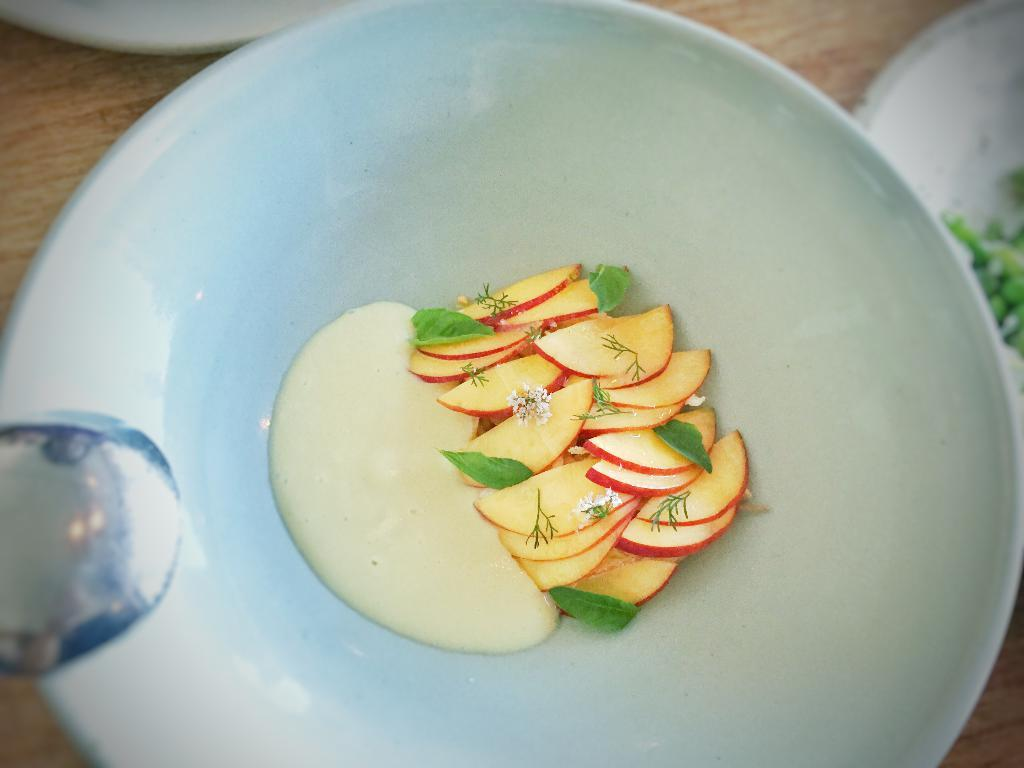What is on the wooden surface in the image? There is a plate on the wooden surface. What is on the plate? The plate contains a food item. Can you describe the food item? The food item has cream, pieces of apple, and leaves. Are there any other items on the plate? Yes, there are other unspecified items on the plate. Can you see any utensils on the plate? A part of a spoon is visible on the plate. How does the food item smile in the image? The food item does not have the ability to smile, as it is an inanimate object. 